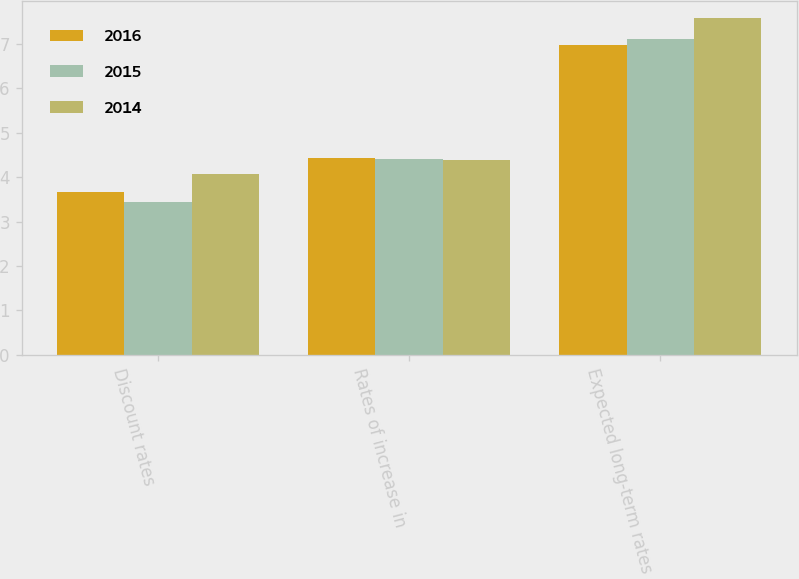Convert chart. <chart><loc_0><loc_0><loc_500><loc_500><stacked_bar_chart><ecel><fcel>Discount rates<fcel>Rates of increase in<fcel>Expected long-term rates of<nl><fcel>2016<fcel>3.67<fcel>4.43<fcel>6.98<nl><fcel>2015<fcel>3.43<fcel>4.41<fcel>7.1<nl><fcel>2014<fcel>4.06<fcel>4.38<fcel>7.58<nl></chart> 